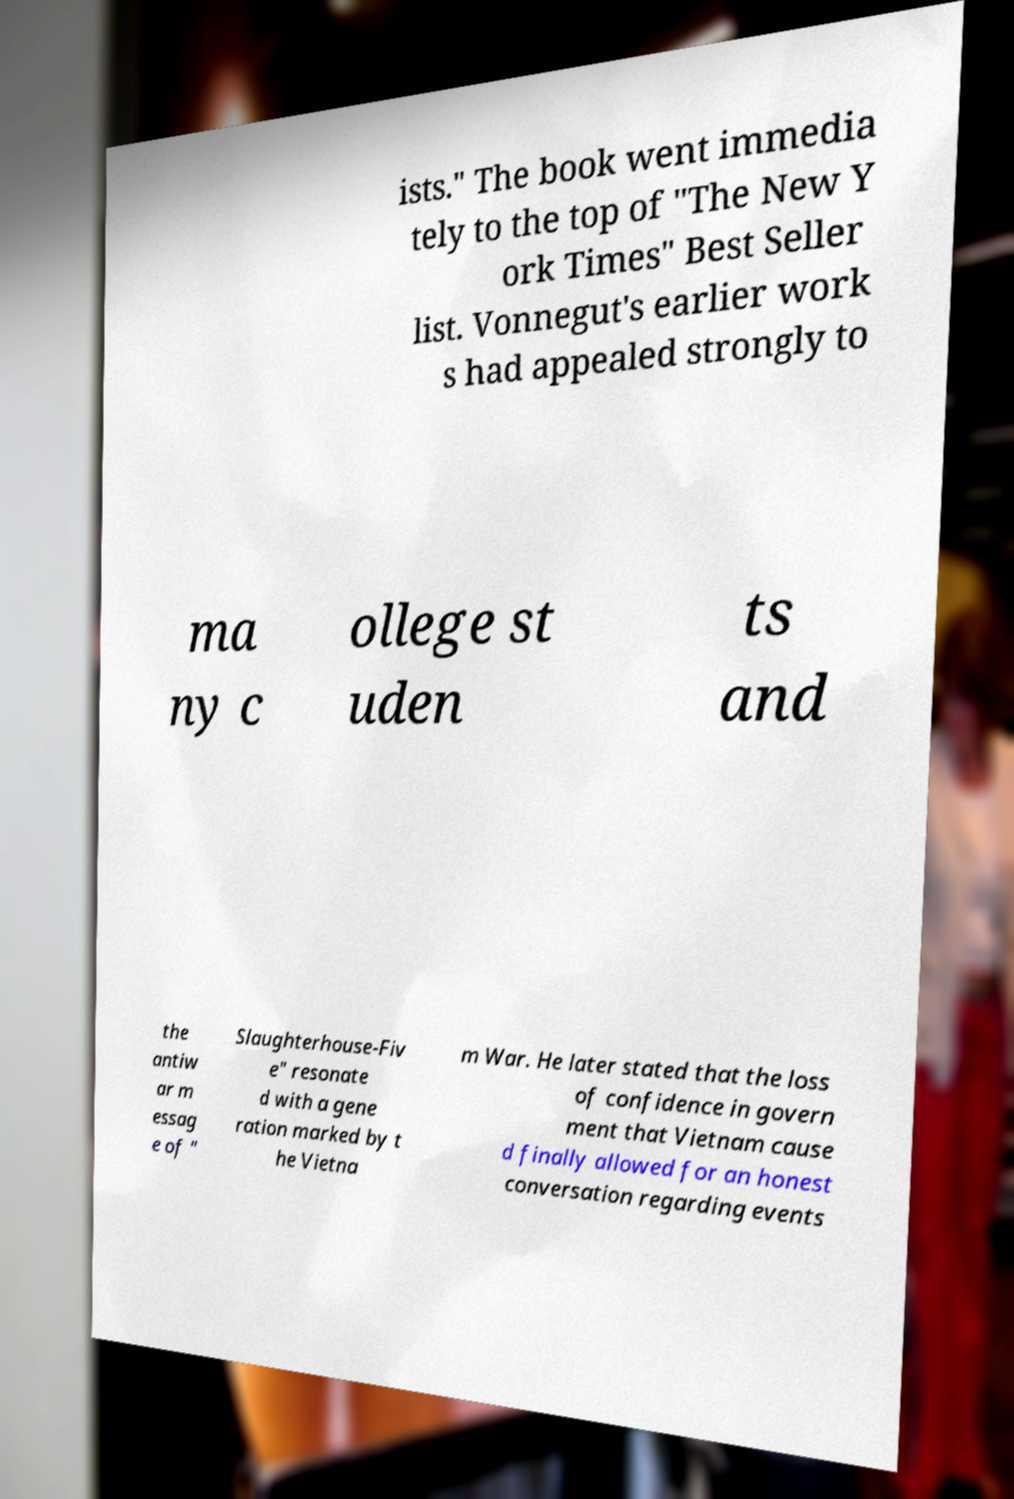Could you assist in decoding the text presented in this image and type it out clearly? ists." The book went immedia tely to the top of "The New Y ork Times" Best Seller list. Vonnegut's earlier work s had appealed strongly to ma ny c ollege st uden ts and the antiw ar m essag e of " Slaughterhouse-Fiv e" resonate d with a gene ration marked by t he Vietna m War. He later stated that the loss of confidence in govern ment that Vietnam cause d finally allowed for an honest conversation regarding events 